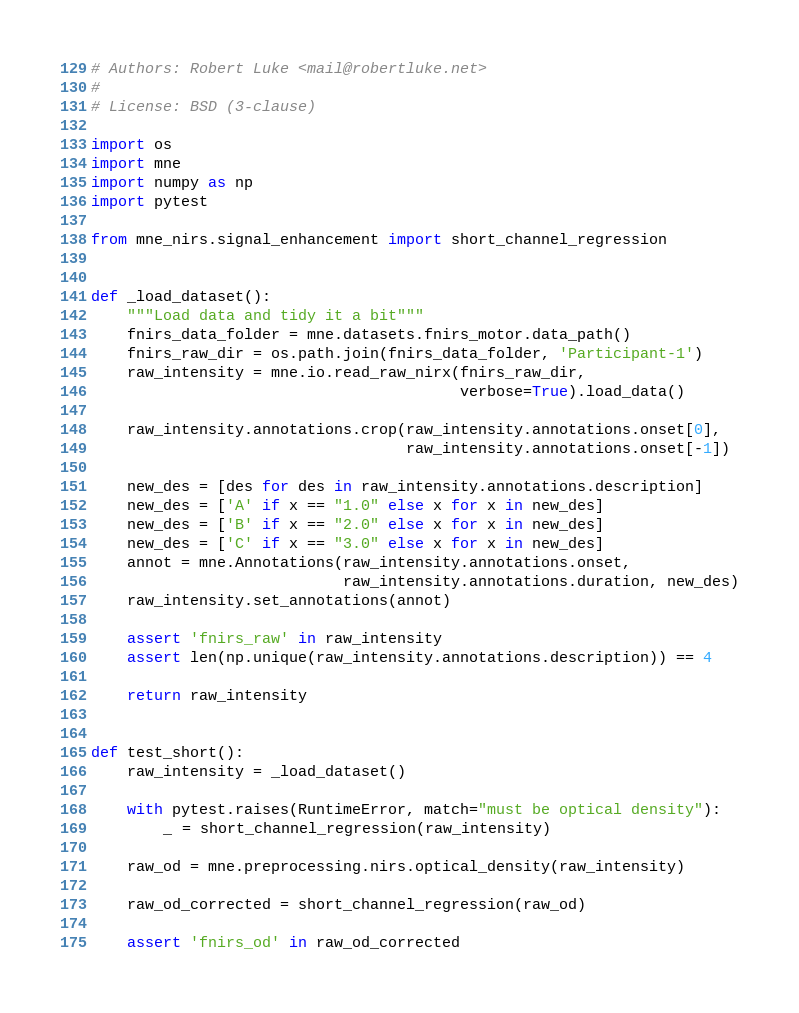Convert code to text. <code><loc_0><loc_0><loc_500><loc_500><_Python_># Authors: Robert Luke <mail@robertluke.net>
#
# License: BSD (3-clause)

import os
import mne
import numpy as np
import pytest

from mne_nirs.signal_enhancement import short_channel_regression


def _load_dataset():
    """Load data and tidy it a bit"""
    fnirs_data_folder = mne.datasets.fnirs_motor.data_path()
    fnirs_raw_dir = os.path.join(fnirs_data_folder, 'Participant-1')
    raw_intensity = mne.io.read_raw_nirx(fnirs_raw_dir,
                                         verbose=True).load_data()

    raw_intensity.annotations.crop(raw_intensity.annotations.onset[0],
                                   raw_intensity.annotations.onset[-1])

    new_des = [des for des in raw_intensity.annotations.description]
    new_des = ['A' if x == "1.0" else x for x in new_des]
    new_des = ['B' if x == "2.0" else x for x in new_des]
    new_des = ['C' if x == "3.0" else x for x in new_des]
    annot = mne.Annotations(raw_intensity.annotations.onset,
                            raw_intensity.annotations.duration, new_des)
    raw_intensity.set_annotations(annot)

    assert 'fnirs_raw' in raw_intensity
    assert len(np.unique(raw_intensity.annotations.description)) == 4

    return raw_intensity


def test_short():
    raw_intensity = _load_dataset()

    with pytest.raises(RuntimeError, match="must be optical density"):
        _ = short_channel_regression(raw_intensity)

    raw_od = mne.preprocessing.nirs.optical_density(raw_intensity)

    raw_od_corrected = short_channel_regression(raw_od)

    assert 'fnirs_od' in raw_od_corrected
</code> 